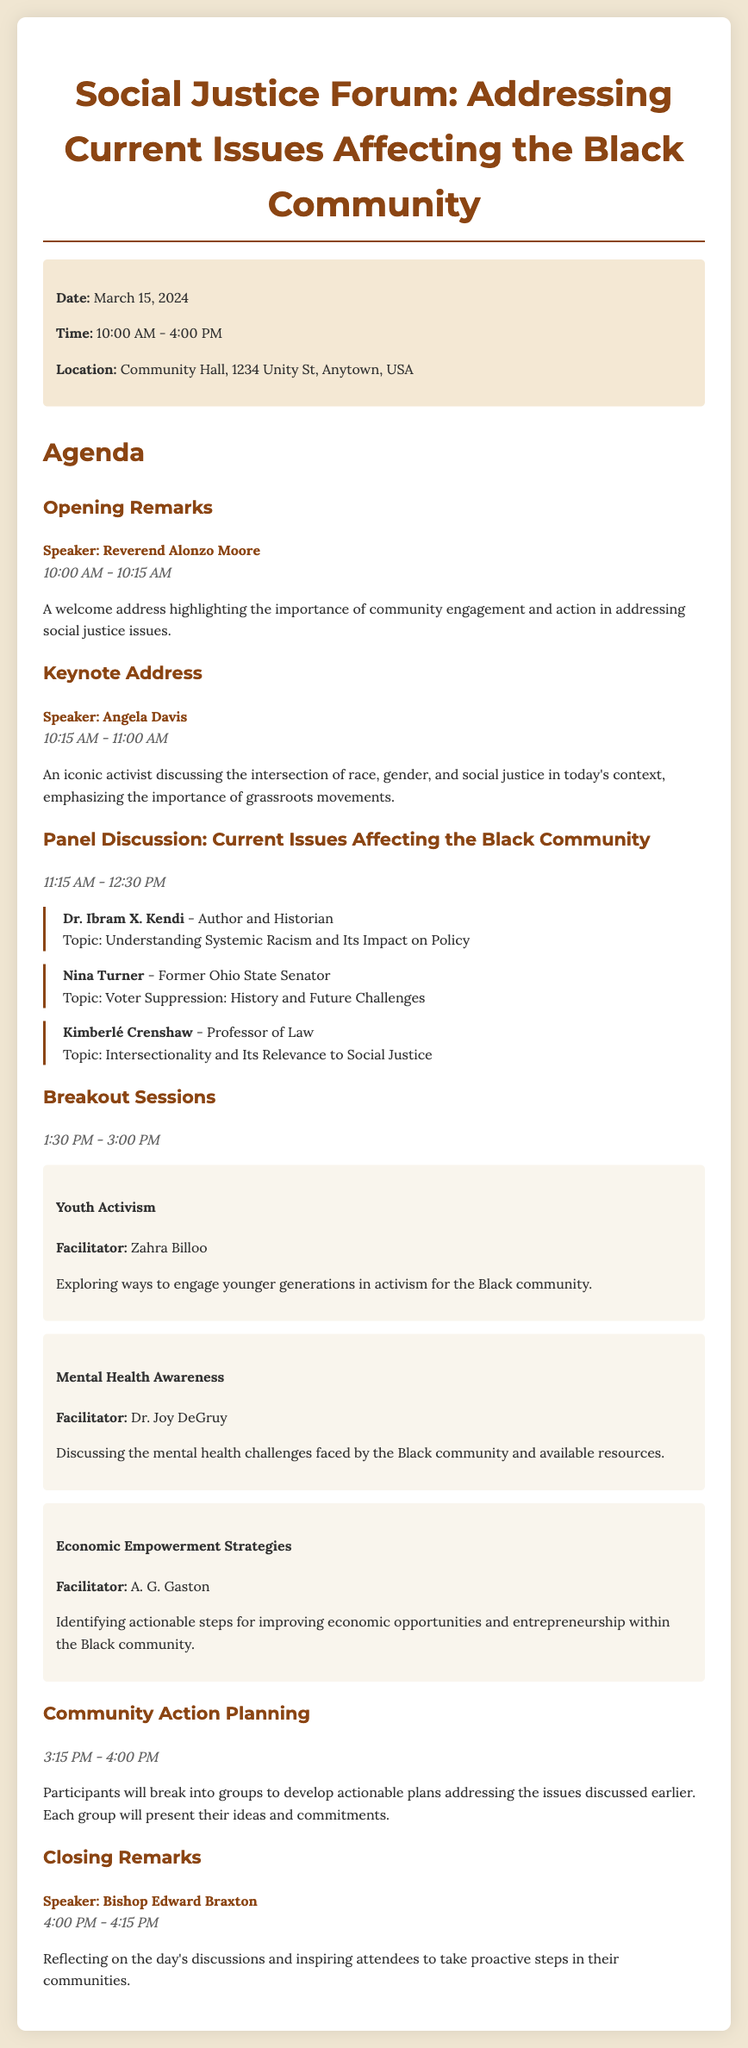What is the date of the forum? The date of the forum is clearly stated in the event details section, which is March 15, 2024.
Answer: March 15, 2024 Who is the keynote speaker? The keynote speaker is mentioned right before the keynote address section, which is Angela Davis.
Answer: Angela Davis What topic will Dr. Ibram X. Kendi discuss? The document lists Dr. Ibram X. Kendi's topic under the panel discussion section, which is Understanding Systemic Racism and Its Impact on Policy.
Answer: Understanding Systemic Racism and Its Impact on Policy What time does the Community Action Planning session start? The start time of the Community Action Planning session is mentioned directly in that section, which is 3:15 PM.
Answer: 3:15 PM How long is the keynote address? The duration of the keynote address is indicated directly in that section, lasting from 10:15 AM to 11:00 AM, which is 45 minutes.
Answer: 45 minutes Who is facilitating the Youth Activism breakout session? The facilitator is listed right below the breakout session title, which is Zahra Billoo.
Answer: Zahra Billoo What is the location of the forum? The location is provided in the event details section, stating Community Hall, 1234 Unity St, Anytown, USA.
Answer: Community Hall, 1234 Unity St, Anytown, USA What is the purpose of the breakout sessions? The purpose of the breakout sessions is explained in brief descriptions following their titles, which is to explore specific topics affecting the Black community.
Answer: Explore specific topics affecting the Black community 